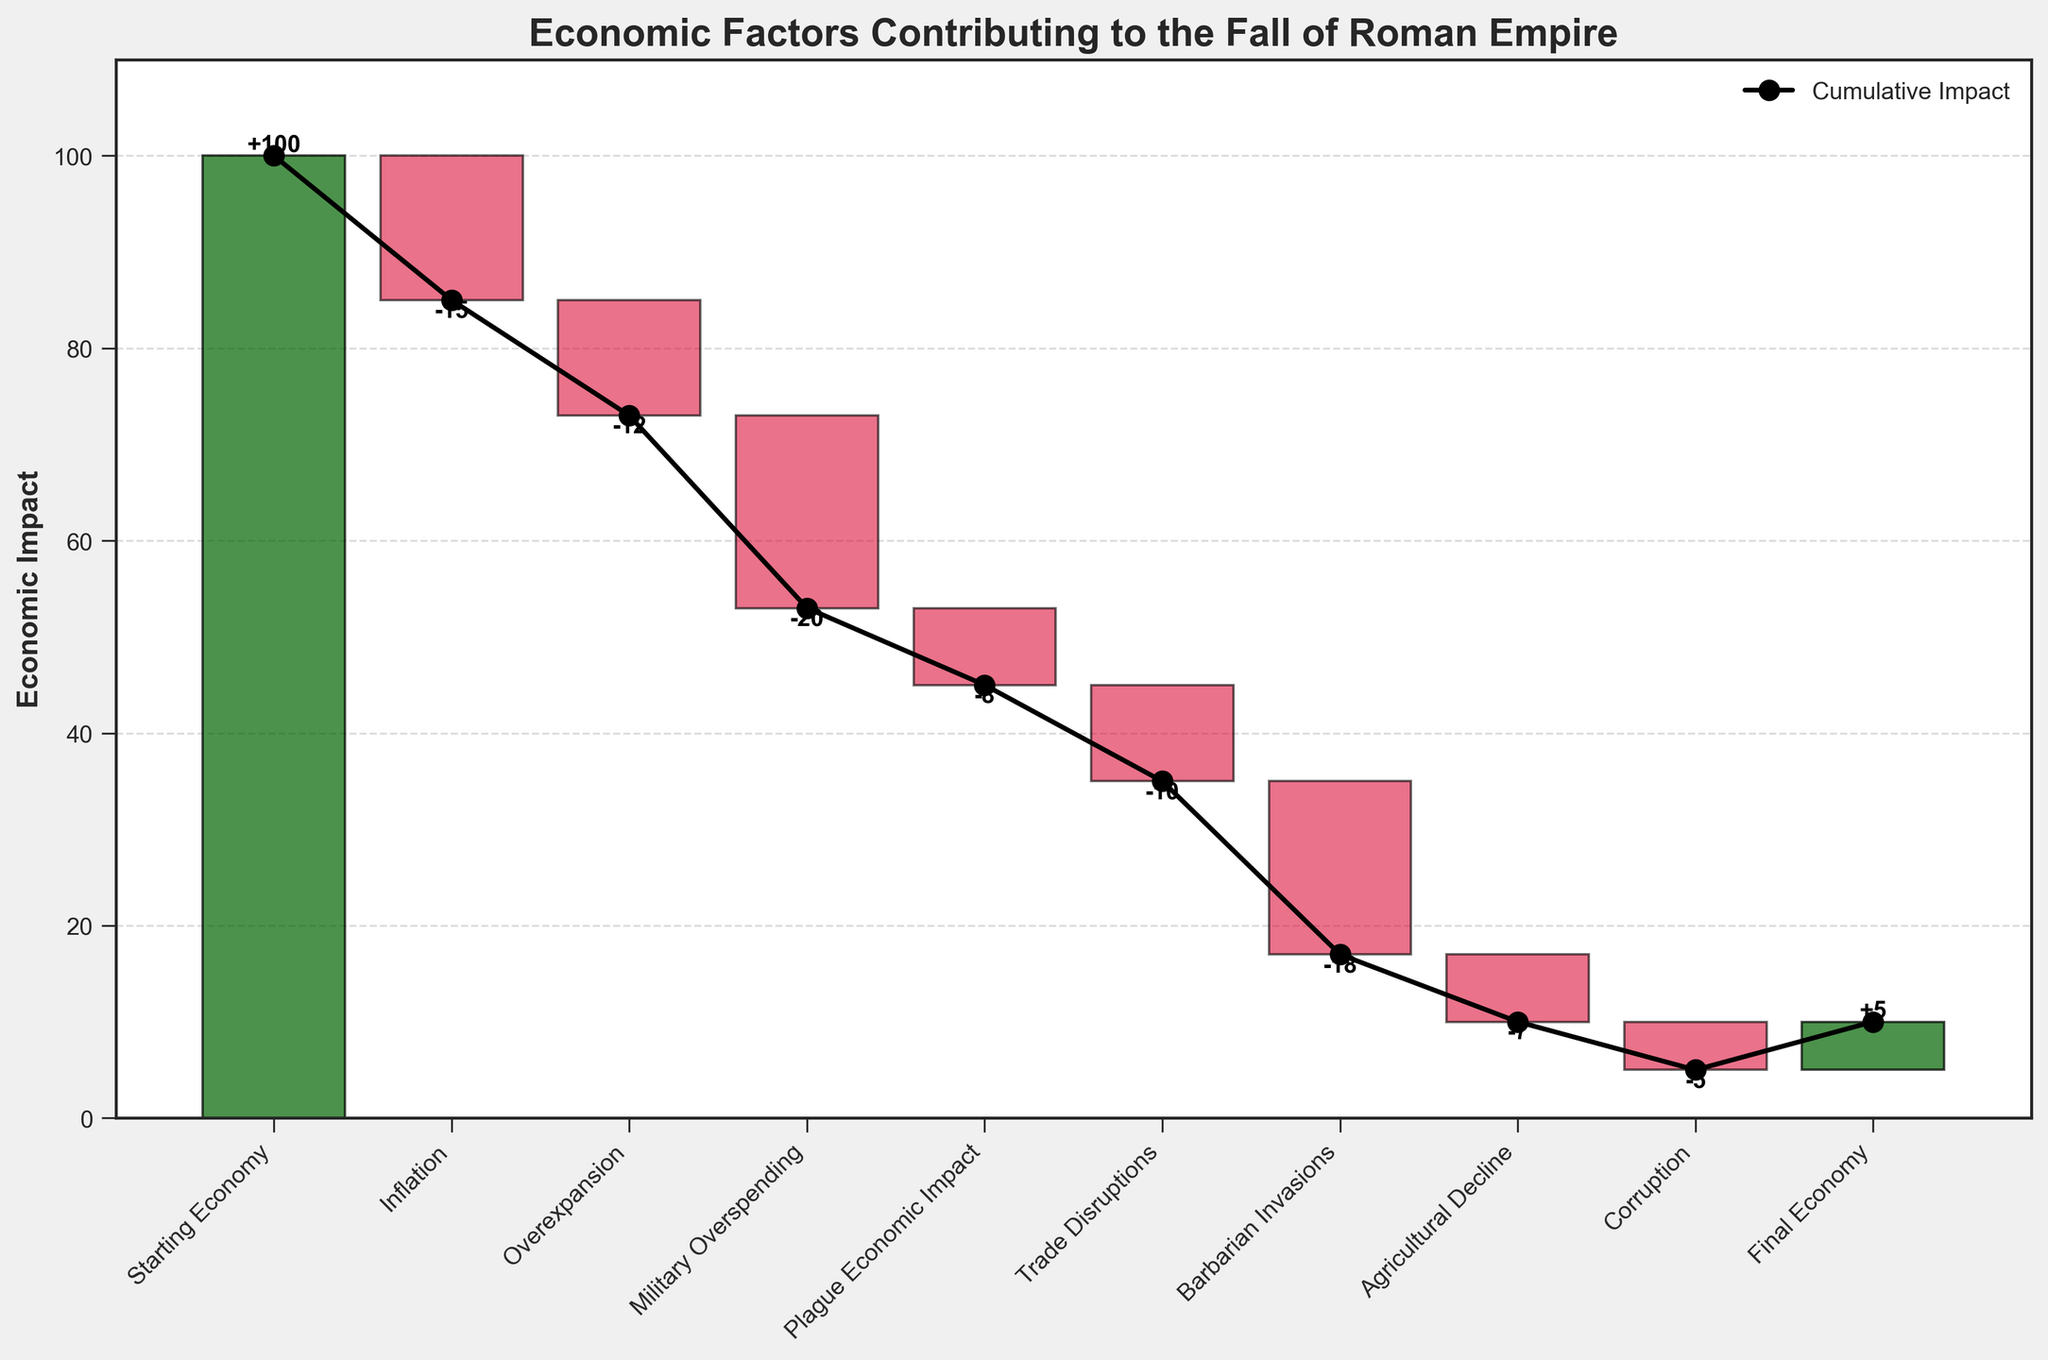What is the title of the chart? The title of the chart is displayed at the top of the figure. It reads 'Economic Factors Contributing to the Fall of Roman Empire'.
Answer: Economic Factors Contributing to the Fall of Roman Empire How many economic factors are listed in the chart? By counting the categories along the x-axis, we can see that there are 9 economic factors, including 'Final Economy' which represents the end result.
Answer: 9 What is the economic impact of Inflation? Locate the category 'Inflation' on the x-axis and refer to the bar position and label associated with it, which shows -15.
Answer: -15 What is the final economic value depicted in the chart? Refer to the category 'Final Economy' towards the end of the x-axis. The bar indicates the final economic value which is 5.
Answer: 5 Which economic factor had the biggest negative impact? Compare the lengths of the red bars and the values indicated on them. The 'Military Overspending' bar is the longest with a value of -20.
Answer: Military Overspending What is the total cumulative economic impact of 'Inflation' and 'Overexpansion'? Sum the individual impacts of 'Inflation' (-15) and 'Overexpansion' (-12). -15 + -12 = -27
Answer: -27 How does the impact of 'Barbarian Invasions' compare to 'Trade Disruptions'? Compare the values of 'Barbarian Invasions' (-18) and 'Trade Disruptions' (-10). 'Barbarian Invasions' has a greater negative impact.
Answer: Barbarian Invasions has a greater negative impact What is the cumulative economic impact up to and including the 'Agricultural Decline'? Track the cumulative sum of values from 'Starting Economy' to 'Agricultural Decline'. 100 + (-15) + (-12) + (-20) + (-8) + (-10) + (-18) + (-7) = 10
Answer: 10 Which factors combined equal the negative impact of 'Military Overspending'? 'Inflation' and 'Trade Disruptions' together sum up to the same negative impact. (-15) + (-10) = (-25), which is not equal. Instead, try 'Inflation' (-15) + 'Overexpansion' (-12) = -27, and 'Plague Economic Impact' (-8) + 'Agricultural Decline' (-7) = (-15) is close but not equal. So the correct factors are: 'Inflation' (-15) and 'Corruption' (-5) equal -20 when combined.
Answer: Inflation and Corruption 